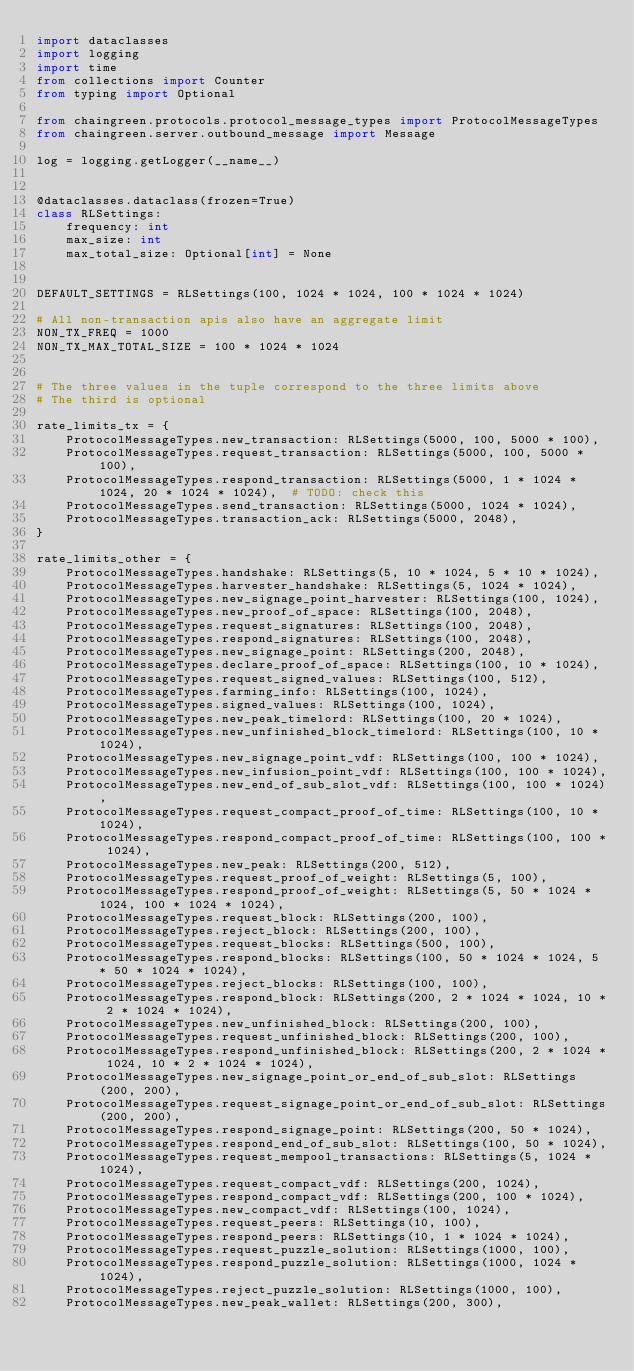<code> <loc_0><loc_0><loc_500><loc_500><_Python_>import dataclasses
import logging
import time
from collections import Counter
from typing import Optional

from chaingreen.protocols.protocol_message_types import ProtocolMessageTypes
from chaingreen.server.outbound_message import Message

log = logging.getLogger(__name__)


@dataclasses.dataclass(frozen=True)
class RLSettings:
    frequency: int
    max_size: int
    max_total_size: Optional[int] = None


DEFAULT_SETTINGS = RLSettings(100, 1024 * 1024, 100 * 1024 * 1024)

# All non-transaction apis also have an aggregate limit
NON_TX_FREQ = 1000
NON_TX_MAX_TOTAL_SIZE = 100 * 1024 * 1024


# The three values in the tuple correspond to the three limits above
# The third is optional

rate_limits_tx = {
    ProtocolMessageTypes.new_transaction: RLSettings(5000, 100, 5000 * 100),
    ProtocolMessageTypes.request_transaction: RLSettings(5000, 100, 5000 * 100),
    ProtocolMessageTypes.respond_transaction: RLSettings(5000, 1 * 1024 * 1024, 20 * 1024 * 1024),  # TODO: check this
    ProtocolMessageTypes.send_transaction: RLSettings(5000, 1024 * 1024),
    ProtocolMessageTypes.transaction_ack: RLSettings(5000, 2048),
}

rate_limits_other = {
    ProtocolMessageTypes.handshake: RLSettings(5, 10 * 1024, 5 * 10 * 1024),
    ProtocolMessageTypes.harvester_handshake: RLSettings(5, 1024 * 1024),
    ProtocolMessageTypes.new_signage_point_harvester: RLSettings(100, 1024),
    ProtocolMessageTypes.new_proof_of_space: RLSettings(100, 2048),
    ProtocolMessageTypes.request_signatures: RLSettings(100, 2048),
    ProtocolMessageTypes.respond_signatures: RLSettings(100, 2048),
    ProtocolMessageTypes.new_signage_point: RLSettings(200, 2048),
    ProtocolMessageTypes.declare_proof_of_space: RLSettings(100, 10 * 1024),
    ProtocolMessageTypes.request_signed_values: RLSettings(100, 512),
    ProtocolMessageTypes.farming_info: RLSettings(100, 1024),
    ProtocolMessageTypes.signed_values: RLSettings(100, 1024),
    ProtocolMessageTypes.new_peak_timelord: RLSettings(100, 20 * 1024),
    ProtocolMessageTypes.new_unfinished_block_timelord: RLSettings(100, 10 * 1024),
    ProtocolMessageTypes.new_signage_point_vdf: RLSettings(100, 100 * 1024),
    ProtocolMessageTypes.new_infusion_point_vdf: RLSettings(100, 100 * 1024),
    ProtocolMessageTypes.new_end_of_sub_slot_vdf: RLSettings(100, 100 * 1024),
    ProtocolMessageTypes.request_compact_proof_of_time: RLSettings(100, 10 * 1024),
    ProtocolMessageTypes.respond_compact_proof_of_time: RLSettings(100, 100 * 1024),
    ProtocolMessageTypes.new_peak: RLSettings(200, 512),
    ProtocolMessageTypes.request_proof_of_weight: RLSettings(5, 100),
    ProtocolMessageTypes.respond_proof_of_weight: RLSettings(5, 50 * 1024 * 1024, 100 * 1024 * 1024),
    ProtocolMessageTypes.request_block: RLSettings(200, 100),
    ProtocolMessageTypes.reject_block: RLSettings(200, 100),
    ProtocolMessageTypes.request_blocks: RLSettings(500, 100),
    ProtocolMessageTypes.respond_blocks: RLSettings(100, 50 * 1024 * 1024, 5 * 50 * 1024 * 1024),
    ProtocolMessageTypes.reject_blocks: RLSettings(100, 100),
    ProtocolMessageTypes.respond_block: RLSettings(200, 2 * 1024 * 1024, 10 * 2 * 1024 * 1024),
    ProtocolMessageTypes.new_unfinished_block: RLSettings(200, 100),
    ProtocolMessageTypes.request_unfinished_block: RLSettings(200, 100),
    ProtocolMessageTypes.respond_unfinished_block: RLSettings(200, 2 * 1024 * 1024, 10 * 2 * 1024 * 1024),
    ProtocolMessageTypes.new_signage_point_or_end_of_sub_slot: RLSettings(200, 200),
    ProtocolMessageTypes.request_signage_point_or_end_of_sub_slot: RLSettings(200, 200),
    ProtocolMessageTypes.respond_signage_point: RLSettings(200, 50 * 1024),
    ProtocolMessageTypes.respond_end_of_sub_slot: RLSettings(100, 50 * 1024),
    ProtocolMessageTypes.request_mempool_transactions: RLSettings(5, 1024 * 1024),
    ProtocolMessageTypes.request_compact_vdf: RLSettings(200, 1024),
    ProtocolMessageTypes.respond_compact_vdf: RLSettings(200, 100 * 1024),
    ProtocolMessageTypes.new_compact_vdf: RLSettings(100, 1024),
    ProtocolMessageTypes.request_peers: RLSettings(10, 100),
    ProtocolMessageTypes.respond_peers: RLSettings(10, 1 * 1024 * 1024),
    ProtocolMessageTypes.request_puzzle_solution: RLSettings(1000, 100),
    ProtocolMessageTypes.respond_puzzle_solution: RLSettings(1000, 1024 * 1024),
    ProtocolMessageTypes.reject_puzzle_solution: RLSettings(1000, 100),
    ProtocolMessageTypes.new_peak_wallet: RLSettings(200, 300),</code> 